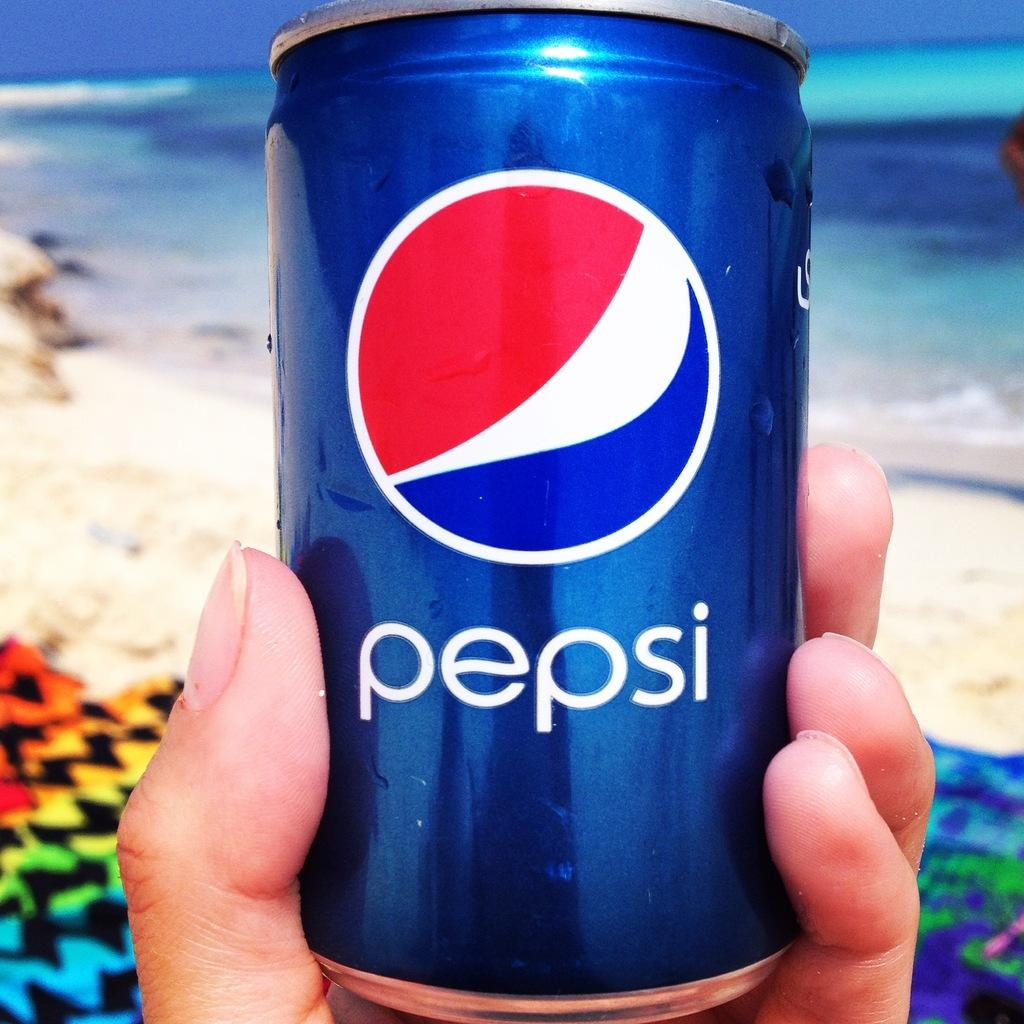<image>
Render a clear and concise summary of the photo. Someone holds a can of Pepsi while on the beach. 